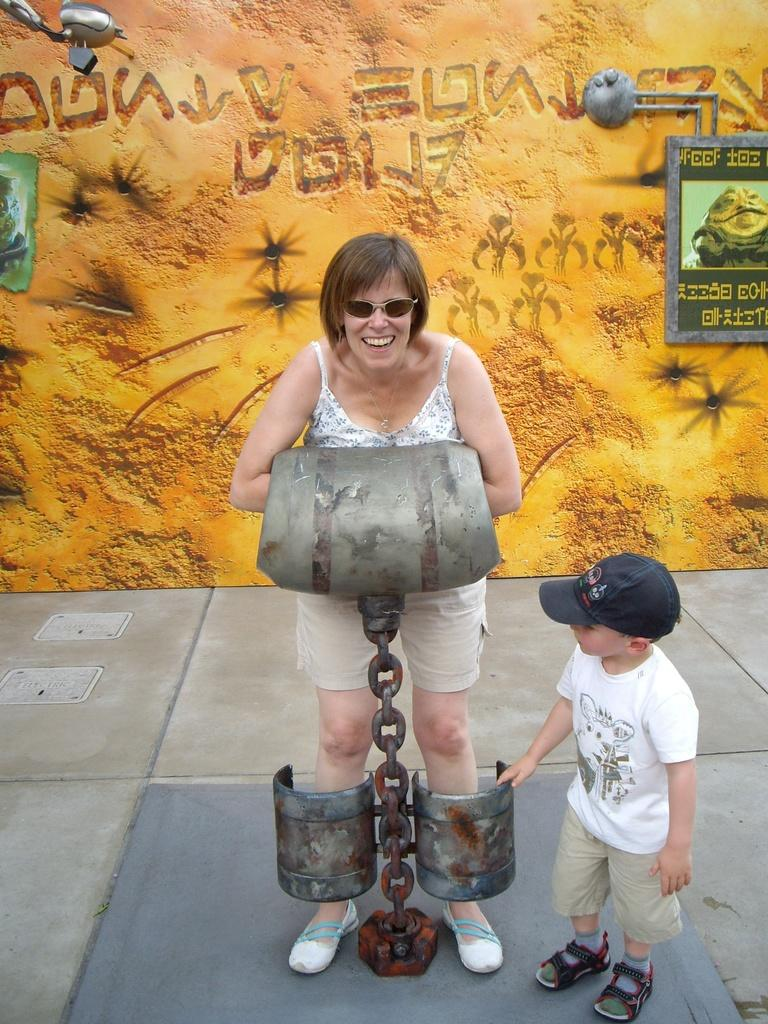Who are the people in the image? There is a woman and a boy in the image. What are the woman and boy doing in the image? The woman and boy are standing. What can be seen on the wall in the image? There is a frame with a picture on the wall in the image. Is there a tent visible in the image? No, there is no tent present in the image. Can you describe the maid in the image? There is no maid present in the image; it only features a woman and a boy. 